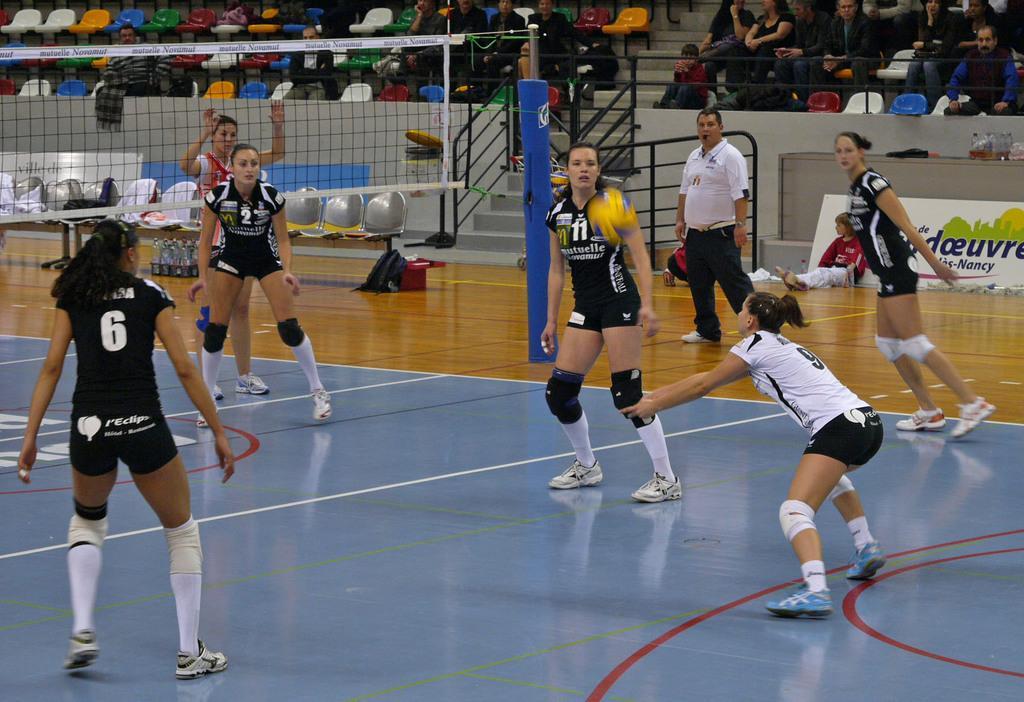Please provide a concise description of this image. This picture is taken in a stadium. In the center there are three women wearing black t-shirts. Towards the right, there are two women wearing white t-shirt and black t-shirt. On the top left, there is a net. On the top, there are people sitting on the chairs and staring at the match. 